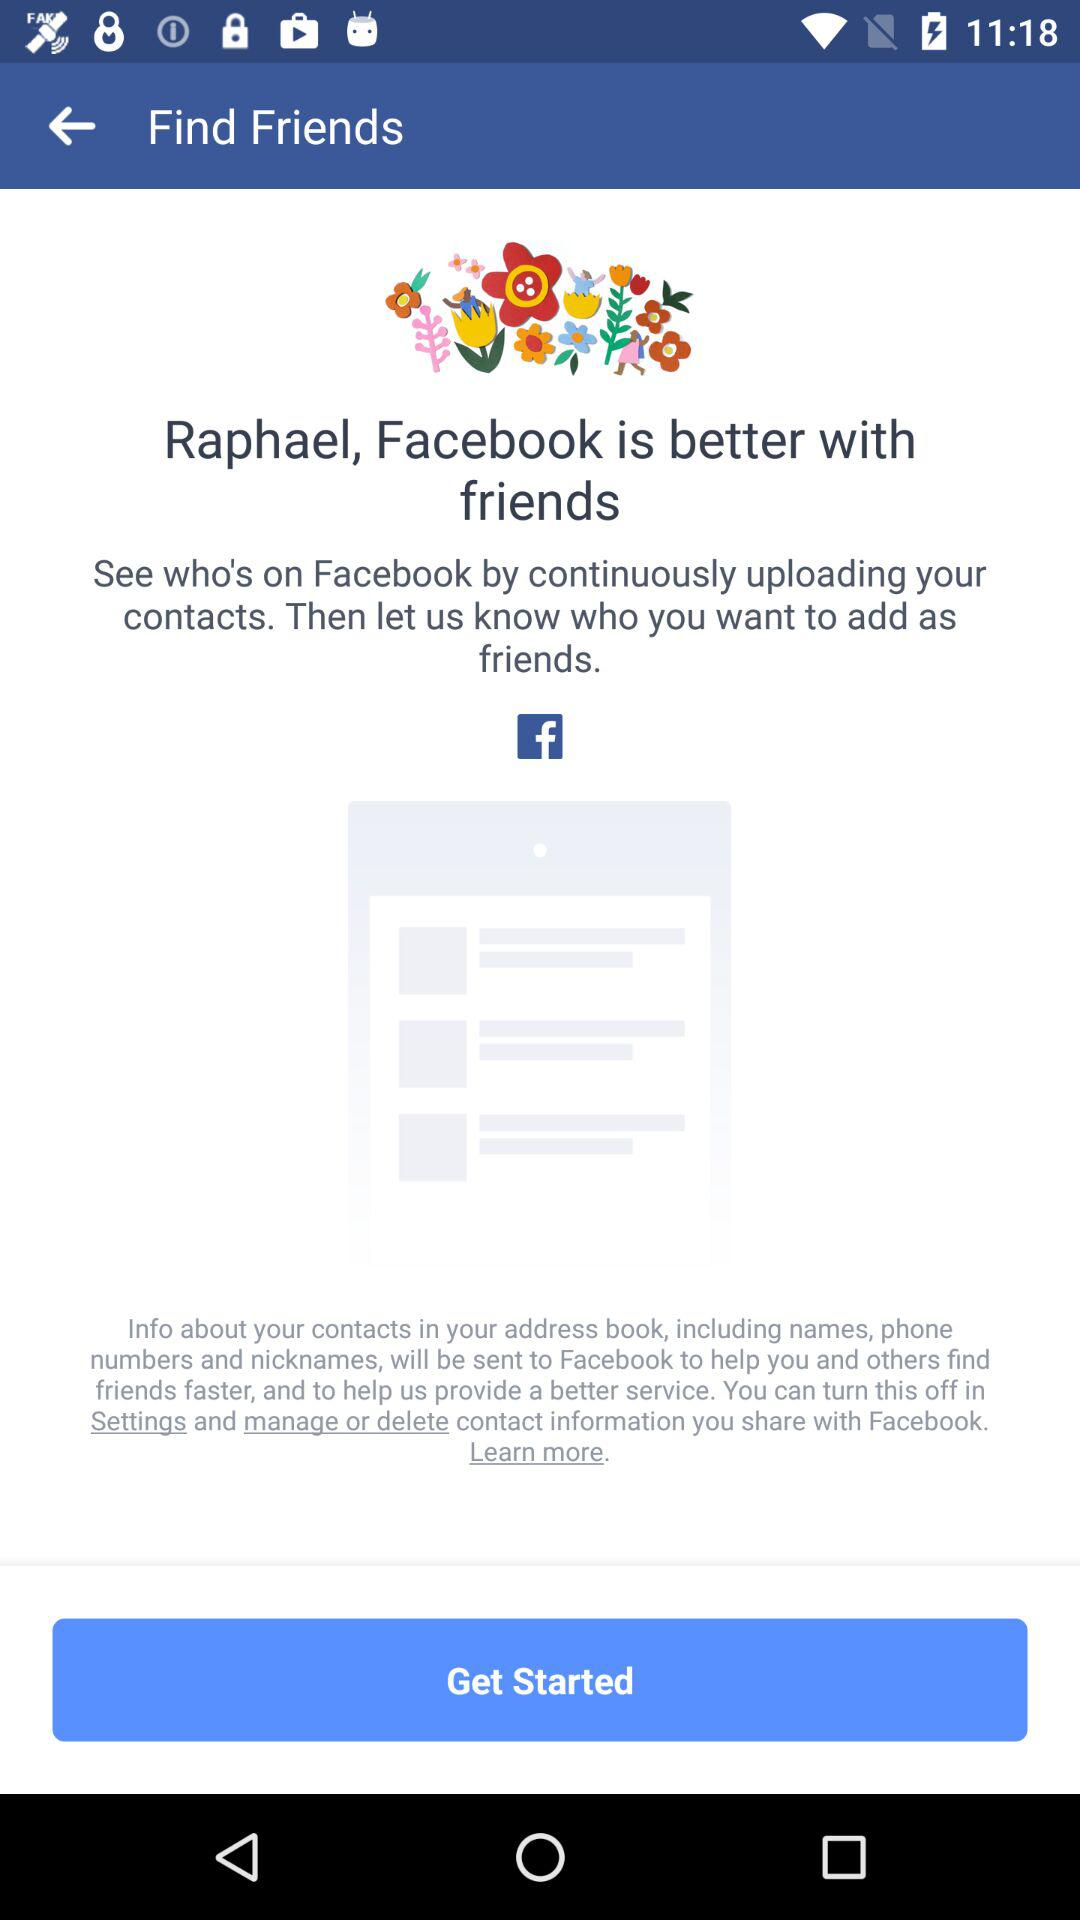What is the user name? The user name is Raphael. 